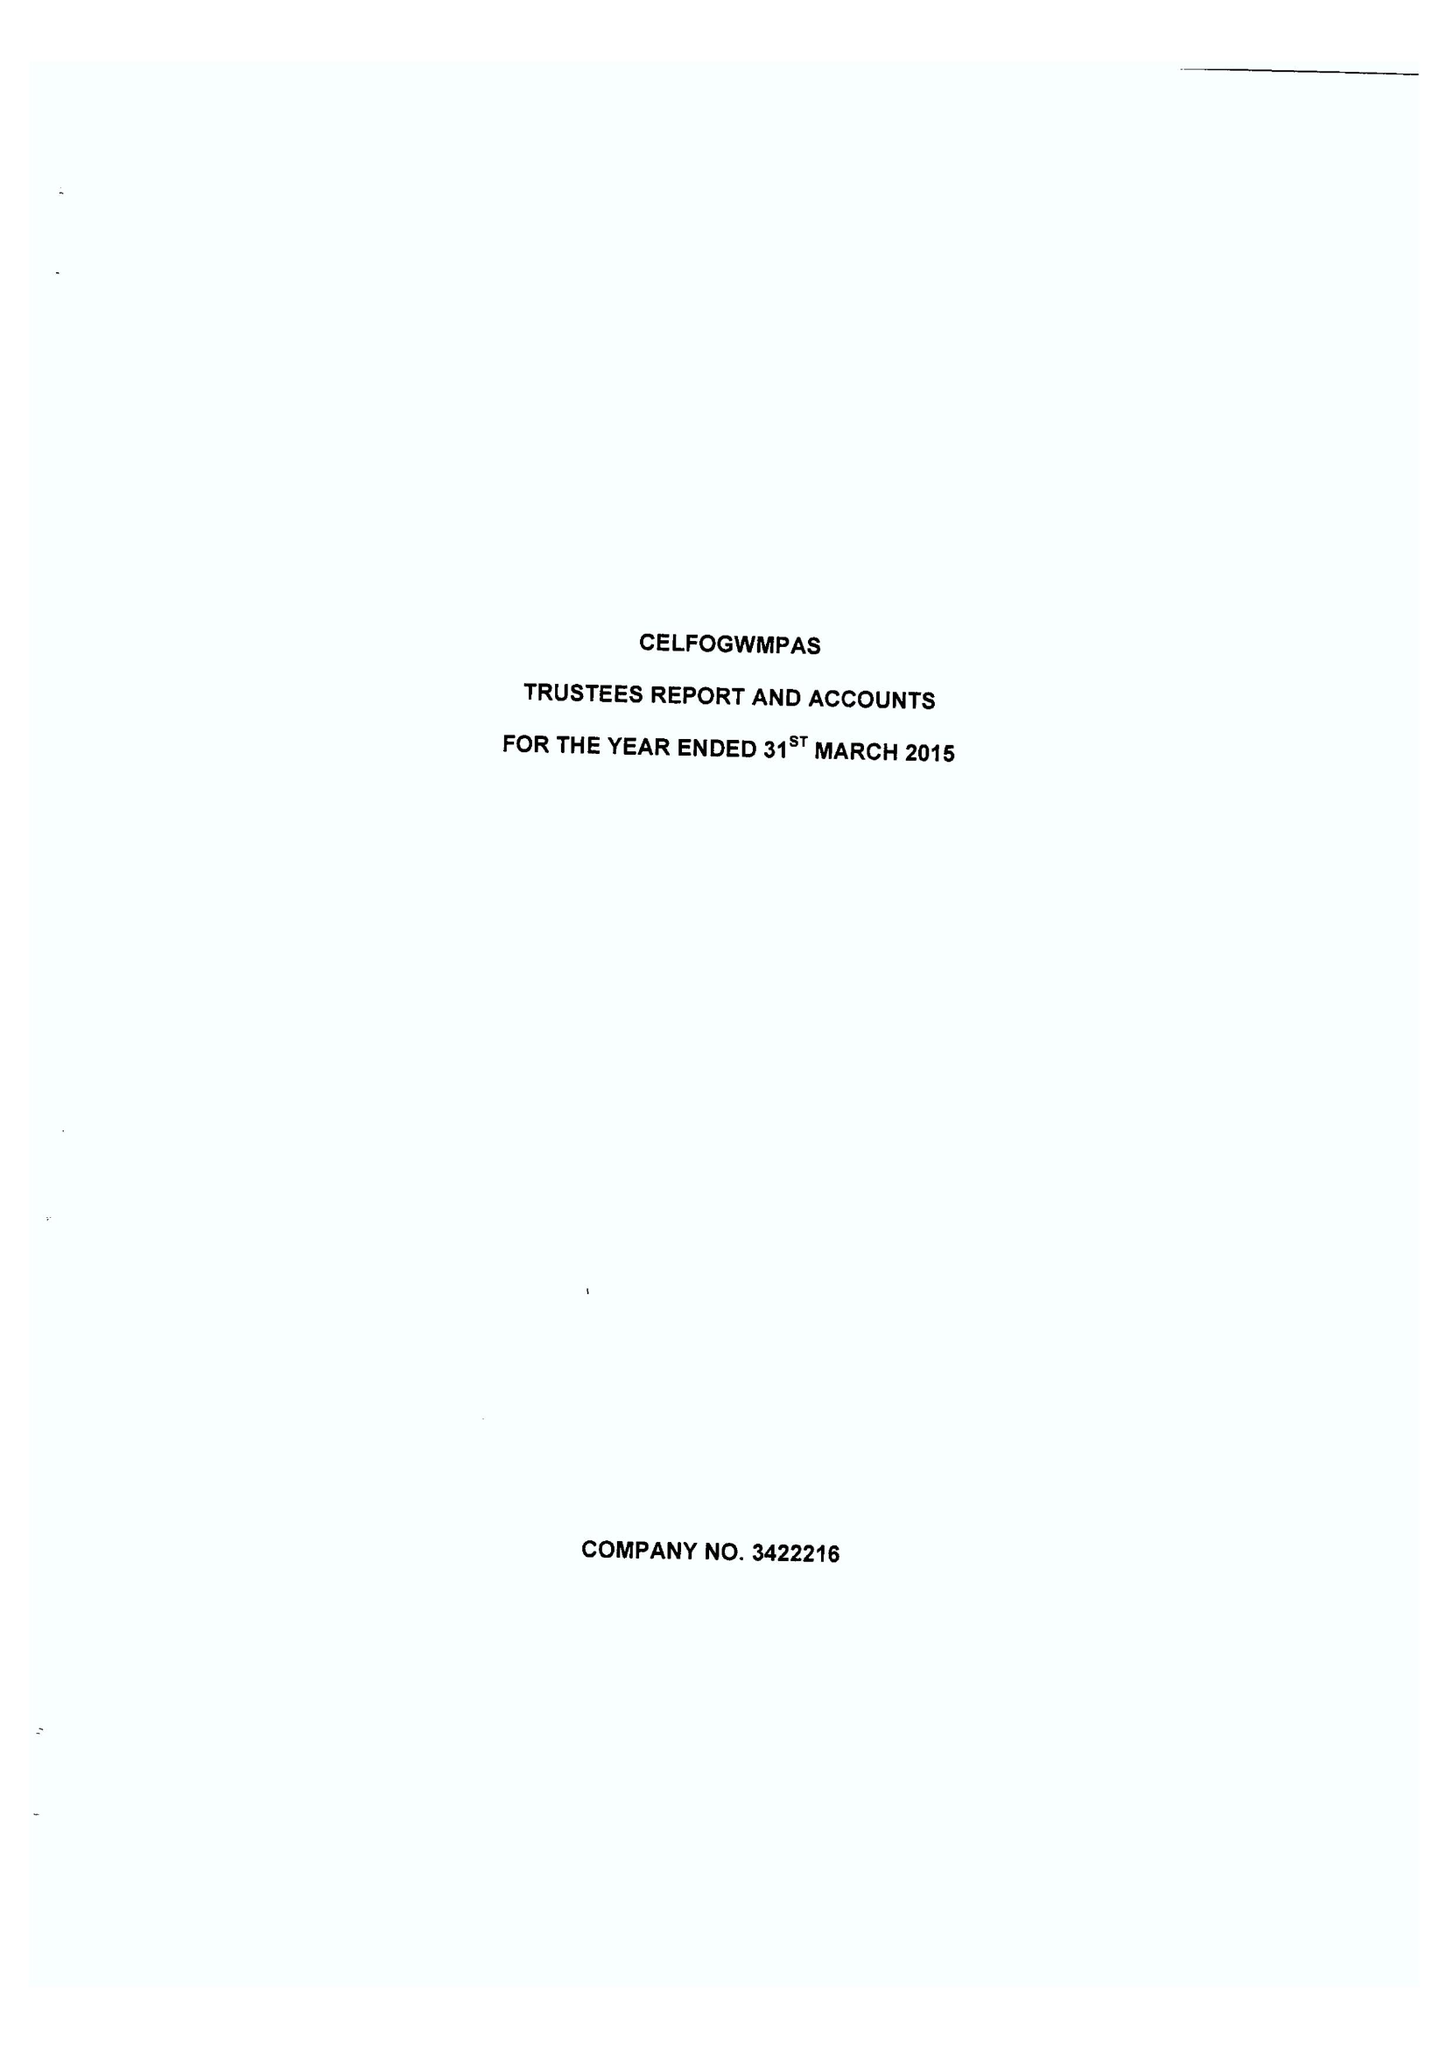What is the value for the spending_annually_in_british_pounds?
Answer the question using a single word or phrase. 107940.00 